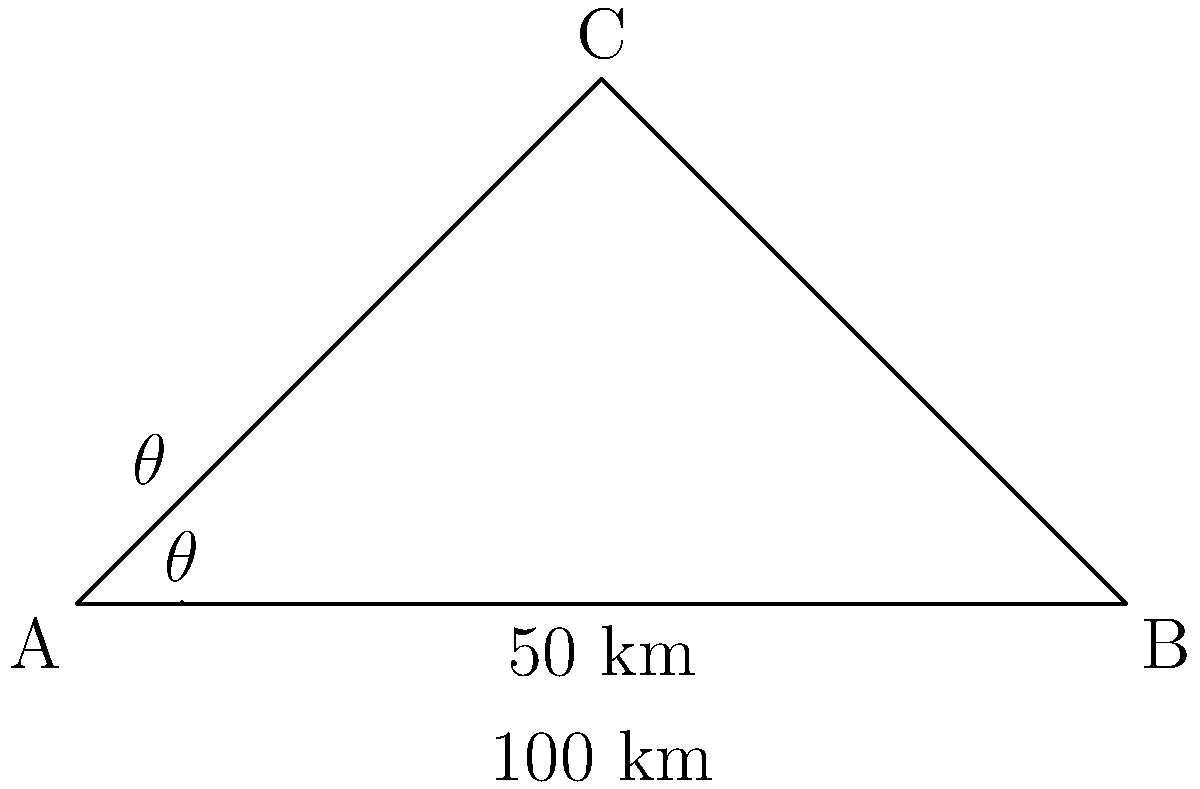A stealth drone needs to fly from point A to point C, passing over point B as shown in the diagram. The distance from A to B is 100 km, and the height of C above the AB line is 50 km. Calculate the optimal flight path angle $\theta$ (in degrees) that minimizes the drone's detectability by minimizing its altitude while still reaching point C. To find the optimal flight path angle $\theta$, we need to use trigonometry in the right-angled triangle ABC:

1) First, we identify that we have a right-angled triangle with the right angle at B.

2) We know the opposite side (BC) is 50 km and the adjacent side (AB) is 100 km.

3) To find the angle $\theta$, we can use the tangent function:

   $\tan(\theta) = \frac{\text{opposite}}{\text{adjacent}} = \frac{50}{100} = 0.5$

4) To get $\theta$, we need to take the inverse tangent (arctangent):

   $\theta = \arctan(0.5)$

5) Converting this to degrees:

   $\theta = \arctan(0.5) \times \frac{180}{\pi} \approx 26.57°$

Therefore, the optimal flight path angle $\theta$ is approximately 26.57°.
Answer: $26.57°$ 